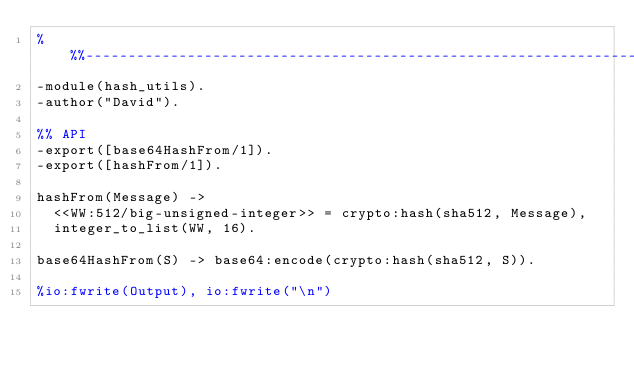<code> <loc_0><loc_0><loc_500><loc_500><_Erlang_>%%%-------------------------------------------------------------------
-module(hash_utils).
-author("David").

%% API
-export([base64HashFrom/1]).
-export([hashFrom/1]).

hashFrom(Message) ->
  <<WW:512/big-unsigned-integer>> = crypto:hash(sha512, Message),
  integer_to_list(WW, 16).

base64HashFrom(S) -> base64:encode(crypto:hash(sha512, S)).

%io:fwrite(Output), io:fwrite("\n")</code> 